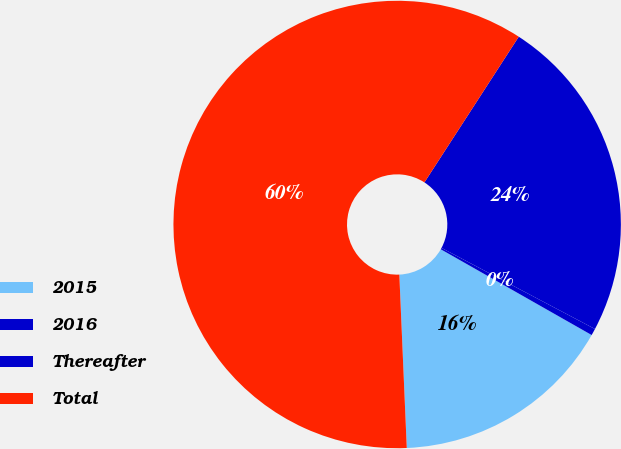Convert chart. <chart><loc_0><loc_0><loc_500><loc_500><pie_chart><fcel>2015<fcel>2016<fcel>Thereafter<fcel>Total<nl><fcel>16.09%<fcel>0.49%<fcel>23.59%<fcel>59.83%<nl></chart> 